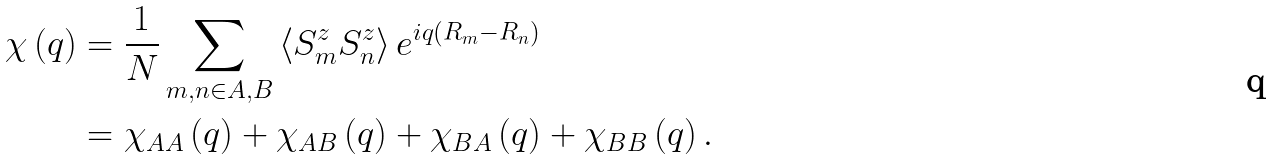<formula> <loc_0><loc_0><loc_500><loc_500>\chi \left ( q \right ) & = \frac { 1 } { N } \sum _ { m , n \in A , B } \left \langle S _ { m } ^ { z } S _ { n } ^ { z } \right \rangle e ^ { i q ( R _ { m } - R _ { n } ) } \\ & = \chi _ { A A } \left ( q \right ) + \chi _ { A B } \left ( q \right ) + \chi _ { B A } \left ( q \right ) + \chi _ { B B } \left ( q \right ) .</formula> 